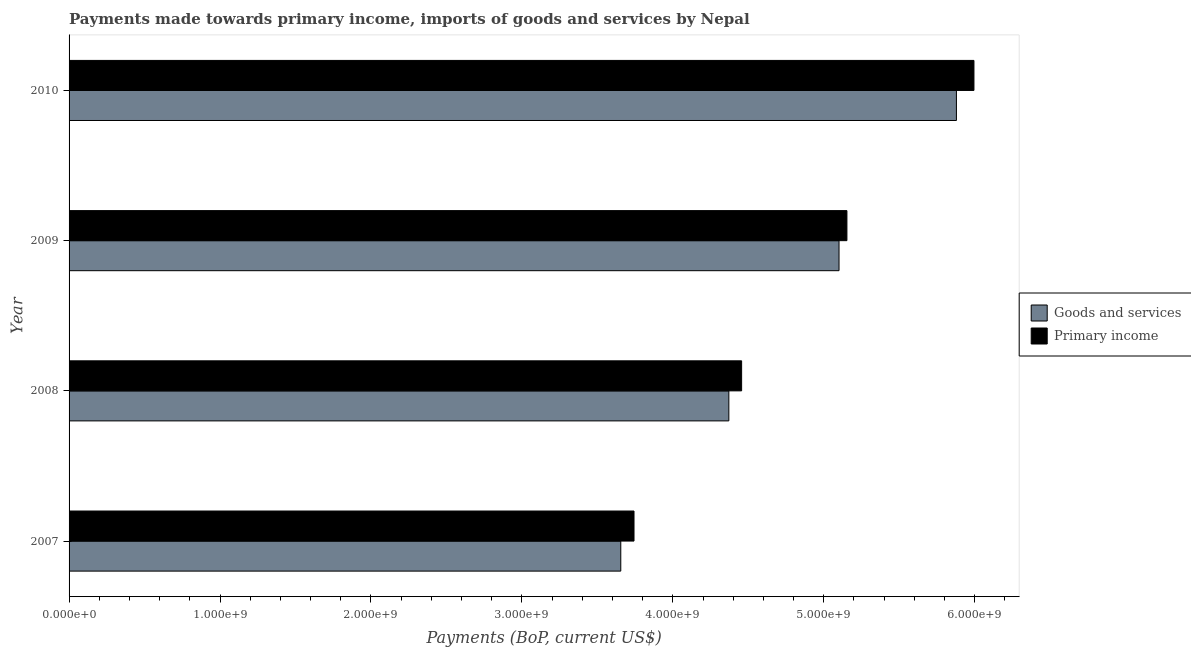How many groups of bars are there?
Give a very brief answer. 4. How many bars are there on the 1st tick from the top?
Your response must be concise. 2. How many bars are there on the 1st tick from the bottom?
Ensure brevity in your answer.  2. In how many cases, is the number of bars for a given year not equal to the number of legend labels?
Keep it short and to the point. 0. What is the payments made towards goods and services in 2010?
Ensure brevity in your answer.  5.88e+09. Across all years, what is the maximum payments made towards primary income?
Give a very brief answer. 5.99e+09. Across all years, what is the minimum payments made towards primary income?
Give a very brief answer. 3.74e+09. In which year was the payments made towards primary income maximum?
Give a very brief answer. 2010. What is the total payments made towards goods and services in the graph?
Make the answer very short. 1.90e+1. What is the difference between the payments made towards goods and services in 2008 and that in 2009?
Ensure brevity in your answer.  -7.30e+08. What is the difference between the payments made towards goods and services in 2009 and the payments made towards primary income in 2008?
Make the answer very short. 6.45e+08. What is the average payments made towards goods and services per year?
Ensure brevity in your answer.  4.75e+09. In the year 2009, what is the difference between the payments made towards goods and services and payments made towards primary income?
Offer a very short reply. -5.23e+07. In how many years, is the payments made towards goods and services greater than 3800000000 US$?
Keep it short and to the point. 3. What is the ratio of the payments made towards goods and services in 2007 to that in 2008?
Provide a short and direct response. 0.84. Is the difference between the payments made towards goods and services in 2007 and 2008 greater than the difference between the payments made towards primary income in 2007 and 2008?
Give a very brief answer. No. What is the difference between the highest and the second highest payments made towards goods and services?
Your answer should be very brief. 7.78e+08. What is the difference between the highest and the lowest payments made towards goods and services?
Provide a succinct answer. 2.22e+09. In how many years, is the payments made towards primary income greater than the average payments made towards primary income taken over all years?
Provide a short and direct response. 2. What does the 1st bar from the top in 2007 represents?
Give a very brief answer. Primary income. What does the 1st bar from the bottom in 2008 represents?
Offer a very short reply. Goods and services. Are all the bars in the graph horizontal?
Your answer should be very brief. Yes. Are the values on the major ticks of X-axis written in scientific E-notation?
Your answer should be compact. Yes. How many legend labels are there?
Provide a succinct answer. 2. How are the legend labels stacked?
Your response must be concise. Vertical. What is the title of the graph?
Your answer should be compact. Payments made towards primary income, imports of goods and services by Nepal. What is the label or title of the X-axis?
Keep it short and to the point. Payments (BoP, current US$). What is the Payments (BoP, current US$) in Goods and services in 2007?
Ensure brevity in your answer.  3.66e+09. What is the Payments (BoP, current US$) in Primary income in 2007?
Provide a succinct answer. 3.74e+09. What is the Payments (BoP, current US$) of Goods and services in 2008?
Offer a terse response. 4.37e+09. What is the Payments (BoP, current US$) of Primary income in 2008?
Offer a terse response. 4.46e+09. What is the Payments (BoP, current US$) in Goods and services in 2009?
Keep it short and to the point. 5.10e+09. What is the Payments (BoP, current US$) in Primary income in 2009?
Keep it short and to the point. 5.15e+09. What is the Payments (BoP, current US$) in Goods and services in 2010?
Offer a terse response. 5.88e+09. What is the Payments (BoP, current US$) of Primary income in 2010?
Make the answer very short. 5.99e+09. Across all years, what is the maximum Payments (BoP, current US$) of Goods and services?
Provide a short and direct response. 5.88e+09. Across all years, what is the maximum Payments (BoP, current US$) of Primary income?
Keep it short and to the point. 5.99e+09. Across all years, what is the minimum Payments (BoP, current US$) of Goods and services?
Ensure brevity in your answer.  3.66e+09. Across all years, what is the minimum Payments (BoP, current US$) of Primary income?
Provide a succinct answer. 3.74e+09. What is the total Payments (BoP, current US$) of Goods and services in the graph?
Your answer should be compact. 1.90e+1. What is the total Payments (BoP, current US$) of Primary income in the graph?
Make the answer very short. 1.93e+1. What is the difference between the Payments (BoP, current US$) in Goods and services in 2007 and that in 2008?
Provide a succinct answer. -7.16e+08. What is the difference between the Payments (BoP, current US$) of Primary income in 2007 and that in 2008?
Give a very brief answer. -7.13e+08. What is the difference between the Payments (BoP, current US$) of Goods and services in 2007 and that in 2009?
Make the answer very short. -1.45e+09. What is the difference between the Payments (BoP, current US$) of Primary income in 2007 and that in 2009?
Offer a very short reply. -1.41e+09. What is the difference between the Payments (BoP, current US$) of Goods and services in 2007 and that in 2010?
Your answer should be very brief. -2.22e+09. What is the difference between the Payments (BoP, current US$) in Primary income in 2007 and that in 2010?
Keep it short and to the point. -2.25e+09. What is the difference between the Payments (BoP, current US$) of Goods and services in 2008 and that in 2009?
Your answer should be very brief. -7.30e+08. What is the difference between the Payments (BoP, current US$) in Primary income in 2008 and that in 2009?
Your response must be concise. -6.98e+08. What is the difference between the Payments (BoP, current US$) of Goods and services in 2008 and that in 2010?
Your answer should be compact. -1.51e+09. What is the difference between the Payments (BoP, current US$) in Primary income in 2008 and that in 2010?
Your answer should be compact. -1.54e+09. What is the difference between the Payments (BoP, current US$) in Goods and services in 2009 and that in 2010?
Ensure brevity in your answer.  -7.78e+08. What is the difference between the Payments (BoP, current US$) of Primary income in 2009 and that in 2010?
Offer a terse response. -8.42e+08. What is the difference between the Payments (BoP, current US$) in Goods and services in 2007 and the Payments (BoP, current US$) in Primary income in 2008?
Ensure brevity in your answer.  -8.01e+08. What is the difference between the Payments (BoP, current US$) of Goods and services in 2007 and the Payments (BoP, current US$) of Primary income in 2009?
Provide a succinct answer. -1.50e+09. What is the difference between the Payments (BoP, current US$) of Goods and services in 2007 and the Payments (BoP, current US$) of Primary income in 2010?
Provide a short and direct response. -2.34e+09. What is the difference between the Payments (BoP, current US$) in Goods and services in 2008 and the Payments (BoP, current US$) in Primary income in 2009?
Make the answer very short. -7.82e+08. What is the difference between the Payments (BoP, current US$) in Goods and services in 2008 and the Payments (BoP, current US$) in Primary income in 2010?
Provide a short and direct response. -1.62e+09. What is the difference between the Payments (BoP, current US$) in Goods and services in 2009 and the Payments (BoP, current US$) in Primary income in 2010?
Offer a very short reply. -8.94e+08. What is the average Payments (BoP, current US$) in Goods and services per year?
Your response must be concise. 4.75e+09. What is the average Payments (BoP, current US$) of Primary income per year?
Offer a terse response. 4.84e+09. In the year 2007, what is the difference between the Payments (BoP, current US$) of Goods and services and Payments (BoP, current US$) of Primary income?
Provide a succinct answer. -8.76e+07. In the year 2008, what is the difference between the Payments (BoP, current US$) of Goods and services and Payments (BoP, current US$) of Primary income?
Keep it short and to the point. -8.46e+07. In the year 2009, what is the difference between the Payments (BoP, current US$) in Goods and services and Payments (BoP, current US$) in Primary income?
Provide a succinct answer. -5.23e+07. In the year 2010, what is the difference between the Payments (BoP, current US$) of Goods and services and Payments (BoP, current US$) of Primary income?
Ensure brevity in your answer.  -1.16e+08. What is the ratio of the Payments (BoP, current US$) of Goods and services in 2007 to that in 2008?
Ensure brevity in your answer.  0.84. What is the ratio of the Payments (BoP, current US$) of Primary income in 2007 to that in 2008?
Offer a terse response. 0.84. What is the ratio of the Payments (BoP, current US$) in Goods and services in 2007 to that in 2009?
Provide a short and direct response. 0.72. What is the ratio of the Payments (BoP, current US$) of Primary income in 2007 to that in 2009?
Provide a succinct answer. 0.73. What is the ratio of the Payments (BoP, current US$) of Goods and services in 2007 to that in 2010?
Make the answer very short. 0.62. What is the ratio of the Payments (BoP, current US$) of Primary income in 2007 to that in 2010?
Make the answer very short. 0.62. What is the ratio of the Payments (BoP, current US$) in Goods and services in 2008 to that in 2009?
Your answer should be very brief. 0.86. What is the ratio of the Payments (BoP, current US$) of Primary income in 2008 to that in 2009?
Provide a succinct answer. 0.86. What is the ratio of the Payments (BoP, current US$) of Goods and services in 2008 to that in 2010?
Ensure brevity in your answer.  0.74. What is the ratio of the Payments (BoP, current US$) of Primary income in 2008 to that in 2010?
Provide a succinct answer. 0.74. What is the ratio of the Payments (BoP, current US$) in Goods and services in 2009 to that in 2010?
Your answer should be compact. 0.87. What is the ratio of the Payments (BoP, current US$) in Primary income in 2009 to that in 2010?
Keep it short and to the point. 0.86. What is the difference between the highest and the second highest Payments (BoP, current US$) of Goods and services?
Provide a short and direct response. 7.78e+08. What is the difference between the highest and the second highest Payments (BoP, current US$) in Primary income?
Your answer should be compact. 8.42e+08. What is the difference between the highest and the lowest Payments (BoP, current US$) of Goods and services?
Your answer should be very brief. 2.22e+09. What is the difference between the highest and the lowest Payments (BoP, current US$) in Primary income?
Give a very brief answer. 2.25e+09. 